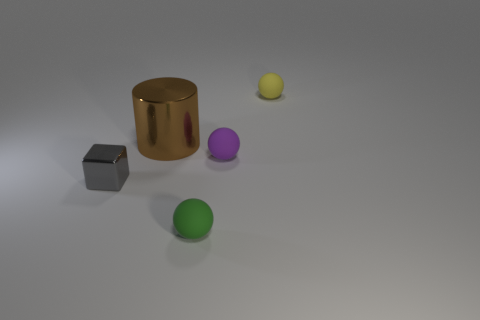Add 3 green rubber objects. How many objects exist? 8 Subtract all purple spheres. How many spheres are left? 2 Subtract all large brown metal cylinders. Subtract all small gray metallic things. How many objects are left? 3 Add 4 big brown cylinders. How many big brown cylinders are left? 5 Add 1 small green objects. How many small green objects exist? 2 Subtract 1 brown cylinders. How many objects are left? 4 Subtract all cubes. How many objects are left? 4 Subtract all blue balls. Subtract all brown cylinders. How many balls are left? 3 